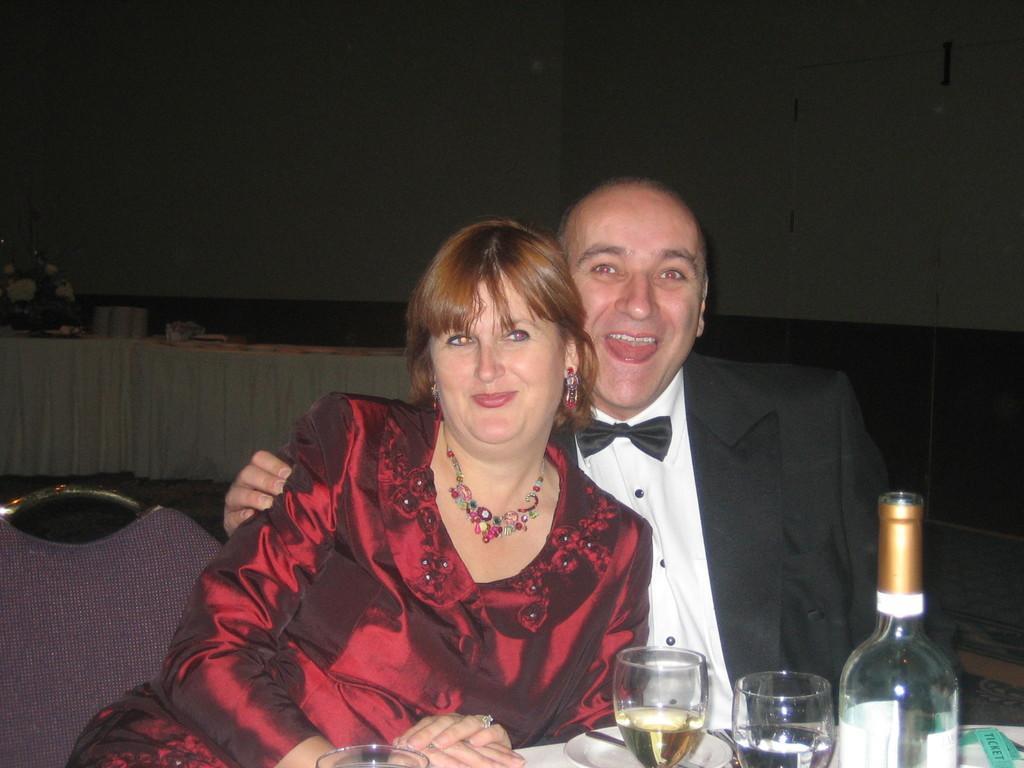Describe this image in one or two sentences. In this image on the right side there is one man who is sitting and smiling. On the left side there is one woman who is sitting and smiling. In front of them there is one table on that table there are two glasses bottles and one plate is there on the background there is a wall, and on the left side there is a table on the table there is one flower bouquet. 